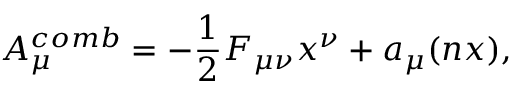<formula> <loc_0><loc_0><loc_500><loc_500>A _ { \mu } ^ { c o m b } = - \frac { 1 } { 2 } F _ { \mu \nu } x ^ { \nu } + a _ { \mu } ( n x ) ,</formula> 